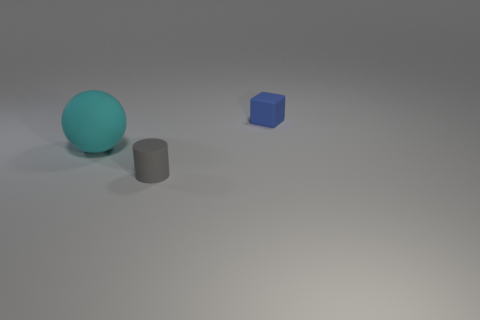Add 1 cyan rubber objects. How many objects exist? 4 Subtract 0 cyan cylinders. How many objects are left? 3 Subtract all cylinders. How many objects are left? 2 Subtract all red cubes. Subtract all gray cylinders. How many cubes are left? 1 Subtract all tiny red matte cylinders. Subtract all tiny objects. How many objects are left? 1 Add 1 big cyan things. How many big cyan things are left? 2 Add 2 cyan rubber balls. How many cyan rubber balls exist? 3 